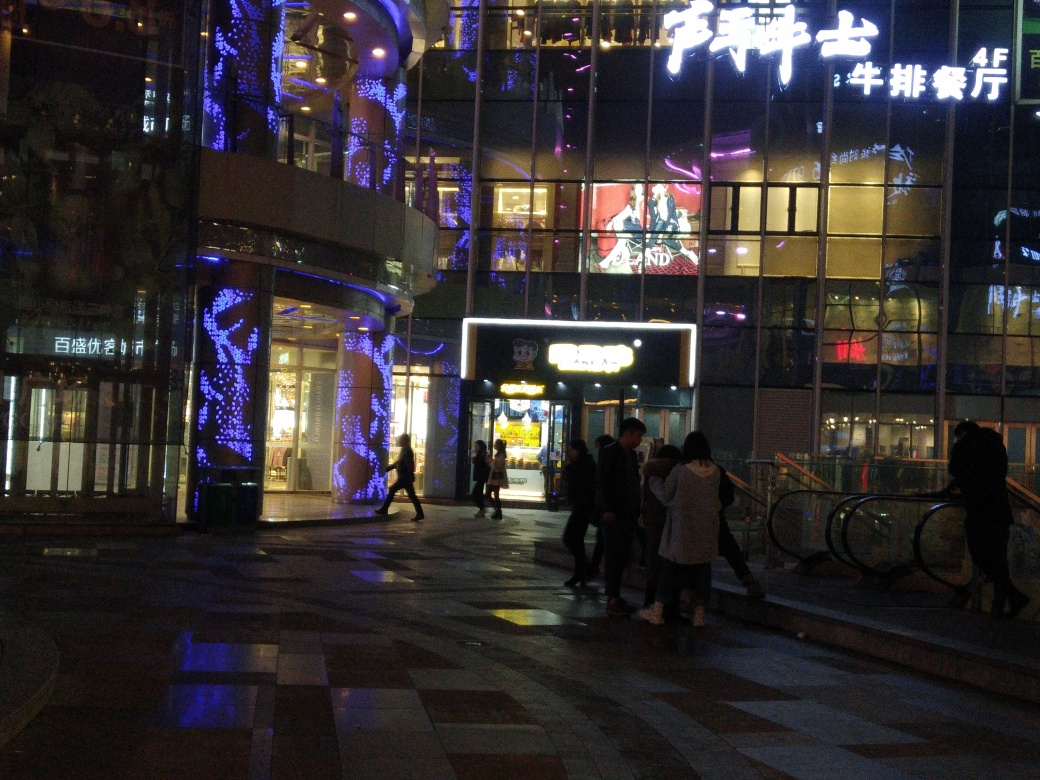What can be seen on the ground? The ground displays a mixture of textures and patterns, including what appears to be tiled sections with some reflective surfaces that catch the lights from the surrounding environment, giving it a somewhat textured look. 